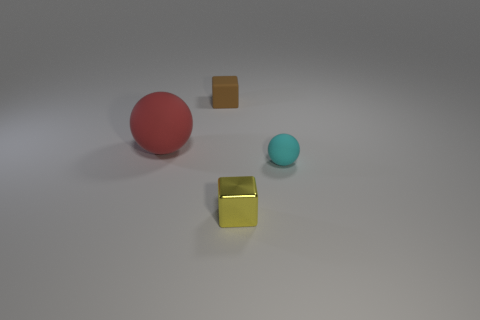Add 1 brown rubber blocks. How many objects exist? 5 Subtract all red objects. Subtract all cyan balls. How many objects are left? 2 Add 2 tiny spheres. How many tiny spheres are left? 3 Add 3 small cyan balls. How many small cyan balls exist? 4 Subtract 0 purple cubes. How many objects are left? 4 